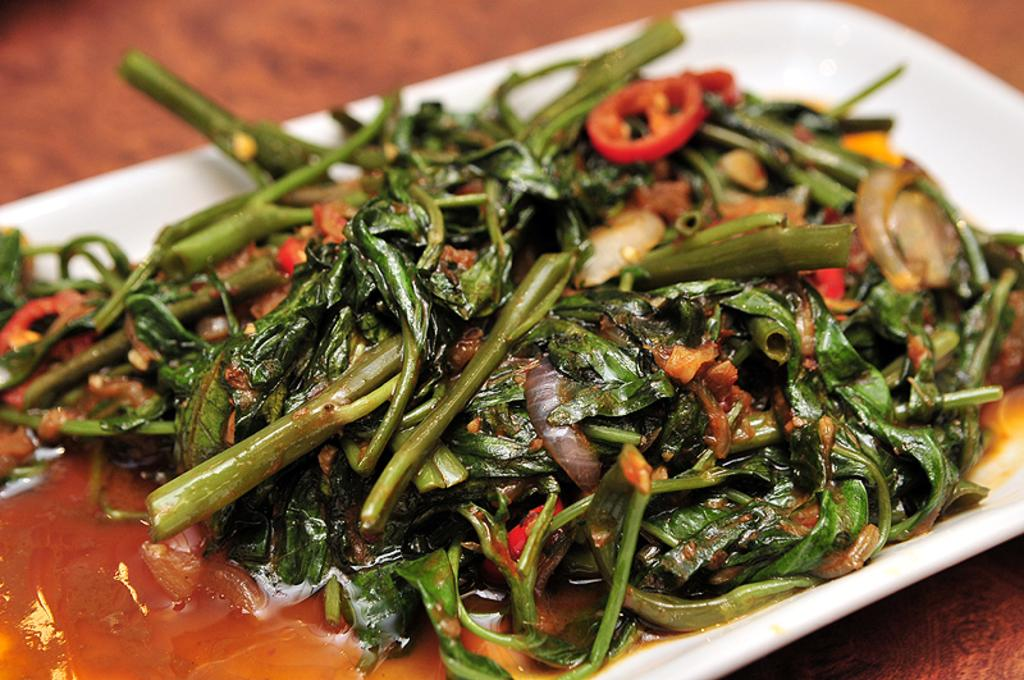What is present in the image that people typically eat? There is food in the image. What is the food placed on in the image? There is a plate in the image. Where is the plate and food located? The food and plate are on a platform. How does the food expand in the image? The food does not expand in the image; it is stationary on the plate. What type of chain is holding the plate in the image? There is no chain present in the image; the plate and food are on a platform. 